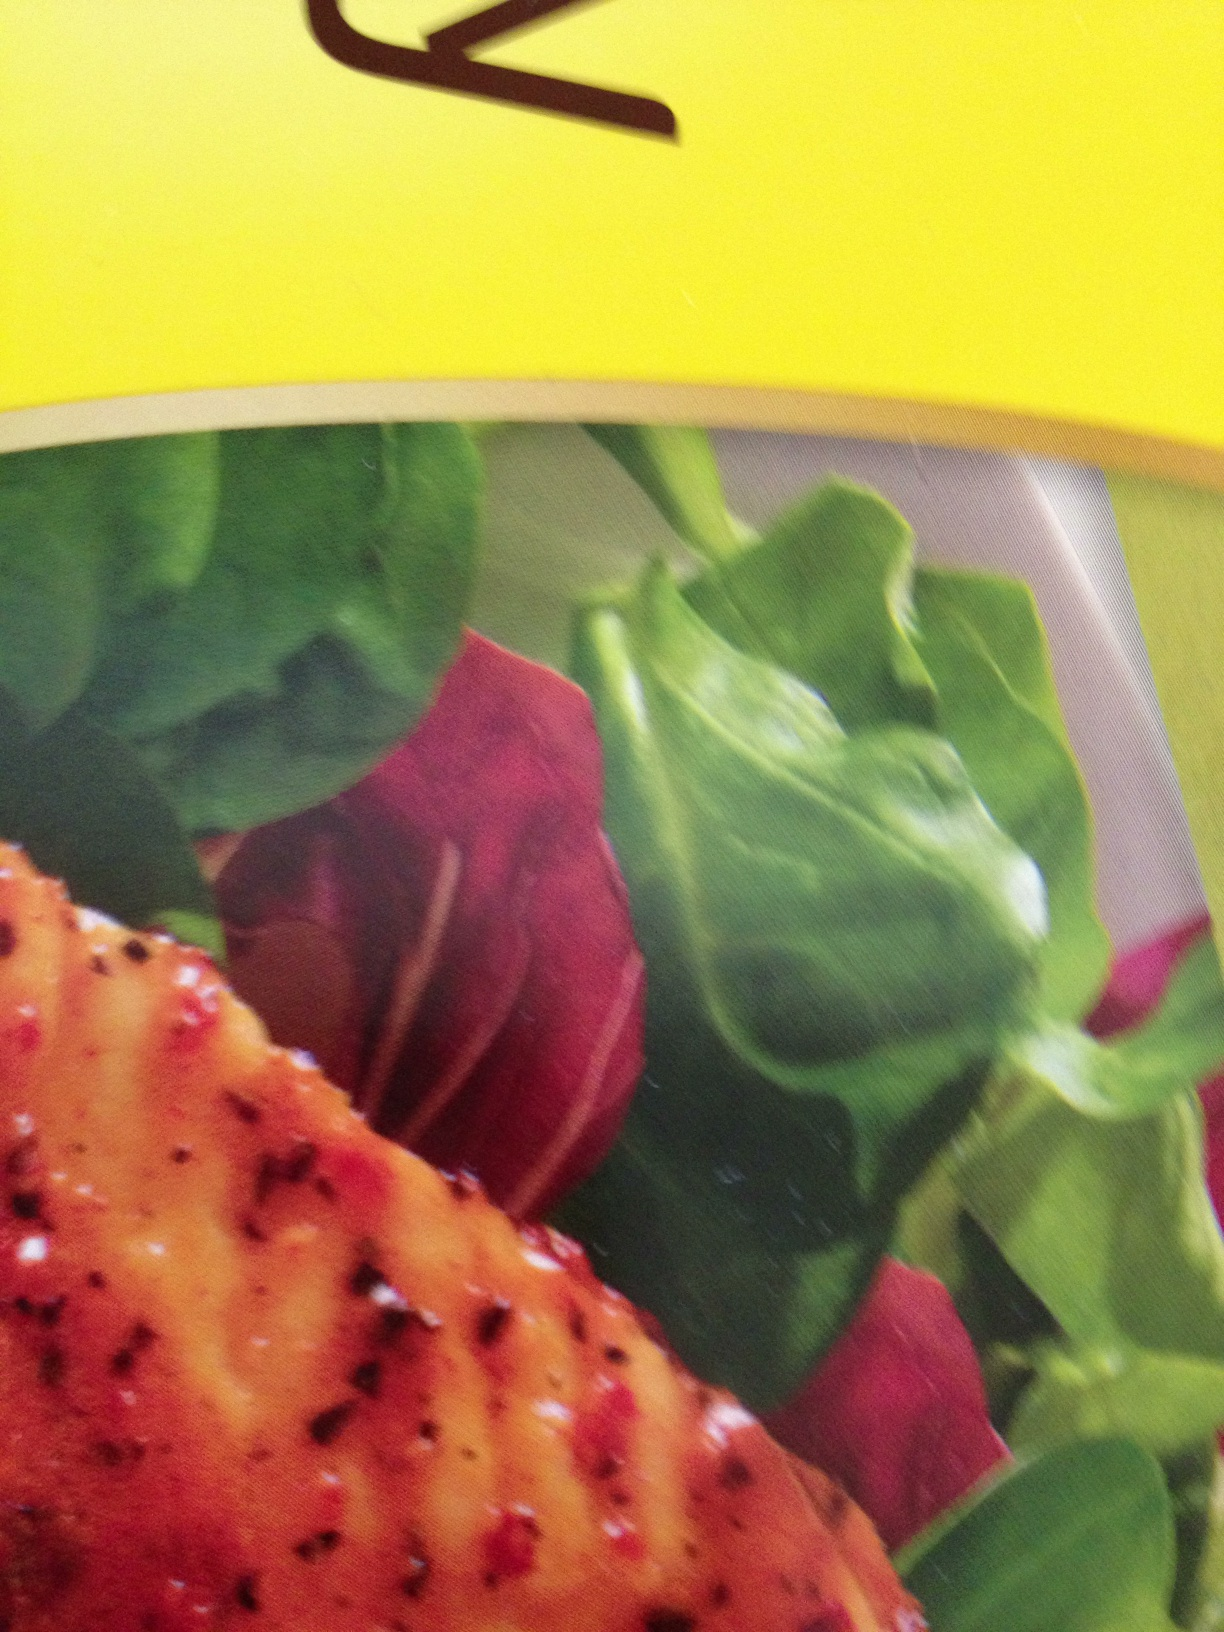Suggest a short and quick variant of this recipe for someone on a tight schedule. For a quick variant of this recipe, you can use pre-cooked grilled chicken slices or even store-bought rotisserie chicken. Simply toss the fresh salad greens and beet slices with a pre-made vinaigrette dressing. Then, top the salad with the chicken slices. It’s nutritious, delicious, and can be prepared in just a few minutes. 